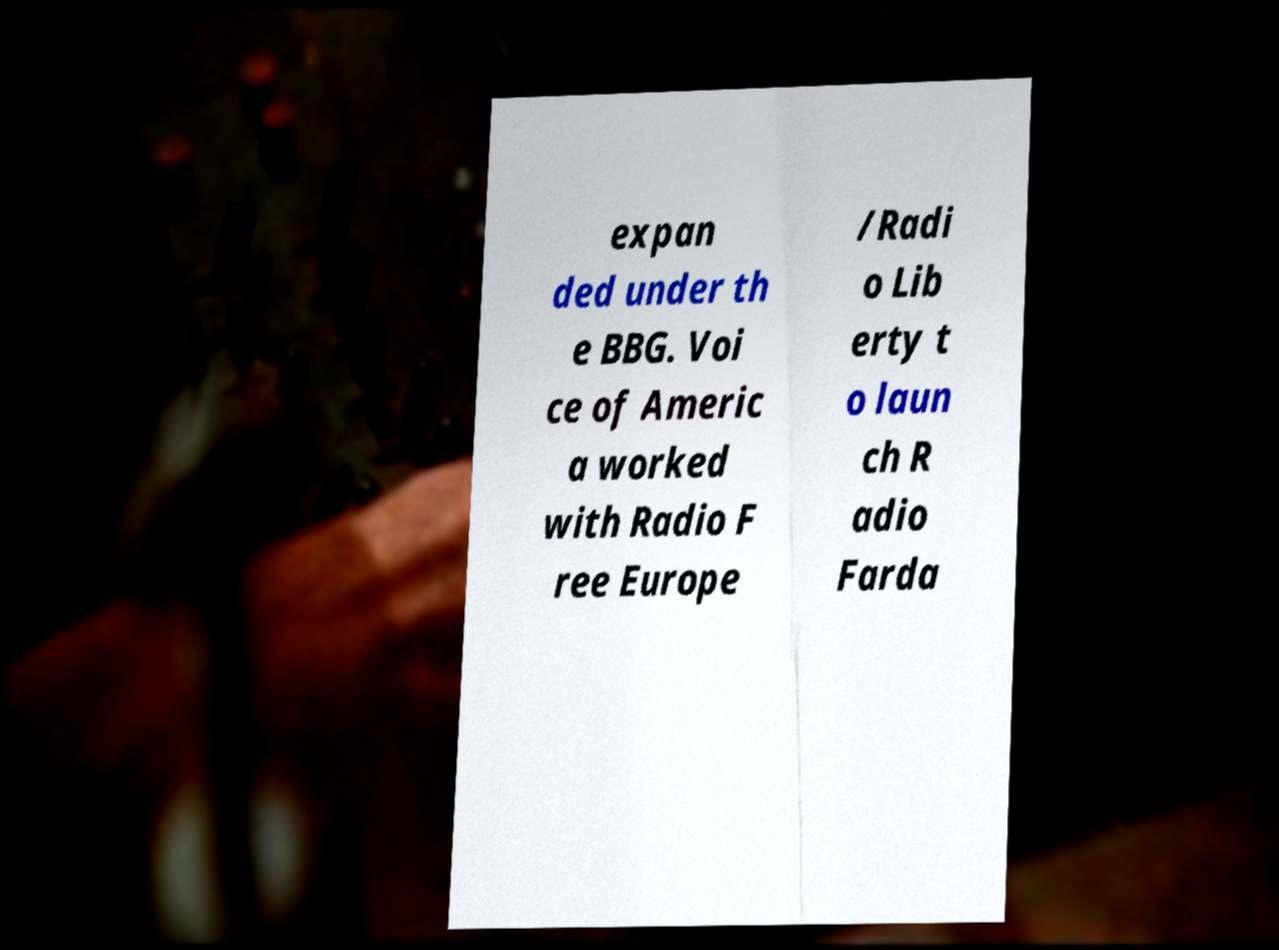What messages or text are displayed in this image? I need them in a readable, typed format. expan ded under th e BBG. Voi ce of Americ a worked with Radio F ree Europe /Radi o Lib erty t o laun ch R adio Farda 